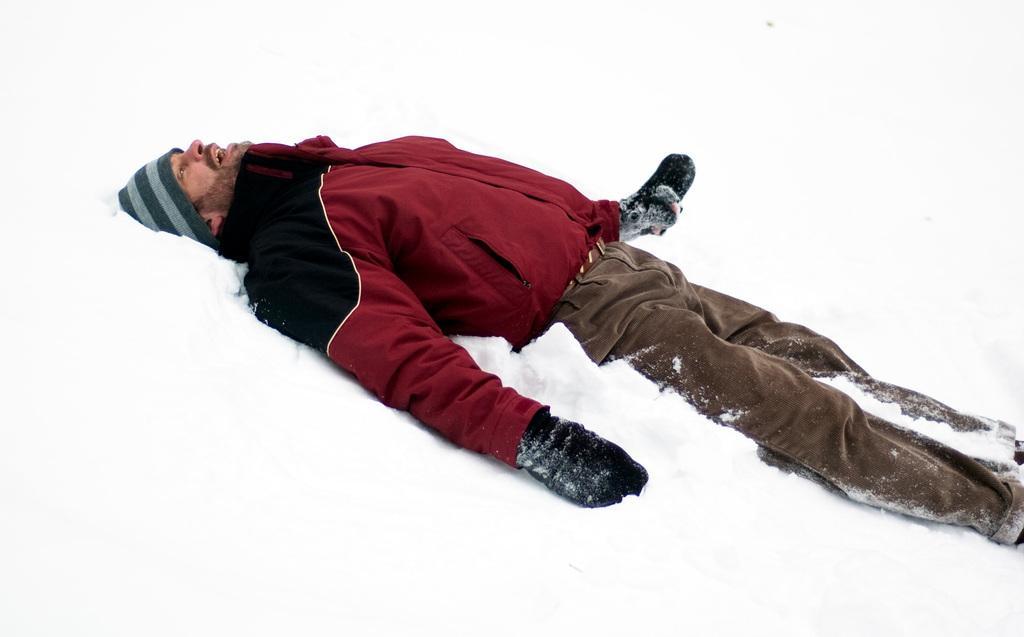Could you give a brief overview of what you see in this image? In this picture we can see a man and snow, he is lying and he is wearing a cap. 